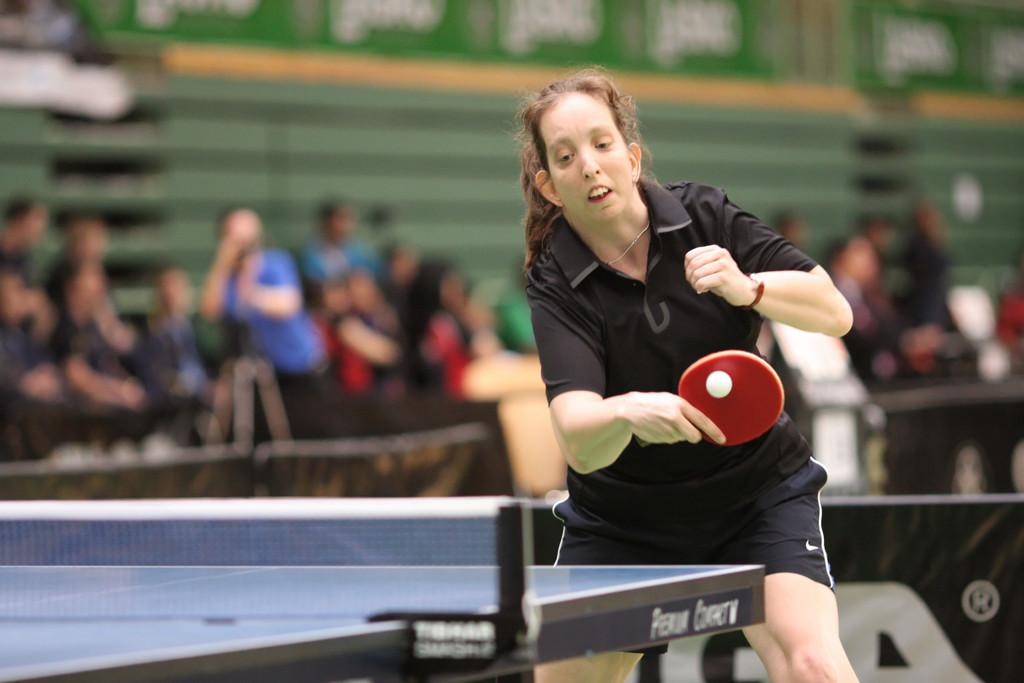Who is the main subject in the image? There is a woman in the image. What is the woman wearing? The woman is wearing a black dress. What is the woman holding in the image? The woman is holding a red bag. What is located in front of the woman? There is a table in front of the woman. What can be seen in the background of the woman? There is a group of people sitting in the background of the woman. What type of organization is responsible for the weather conditions in the image? There is no mention of weather conditions in the image, and therefore no organization can be associated with it. 